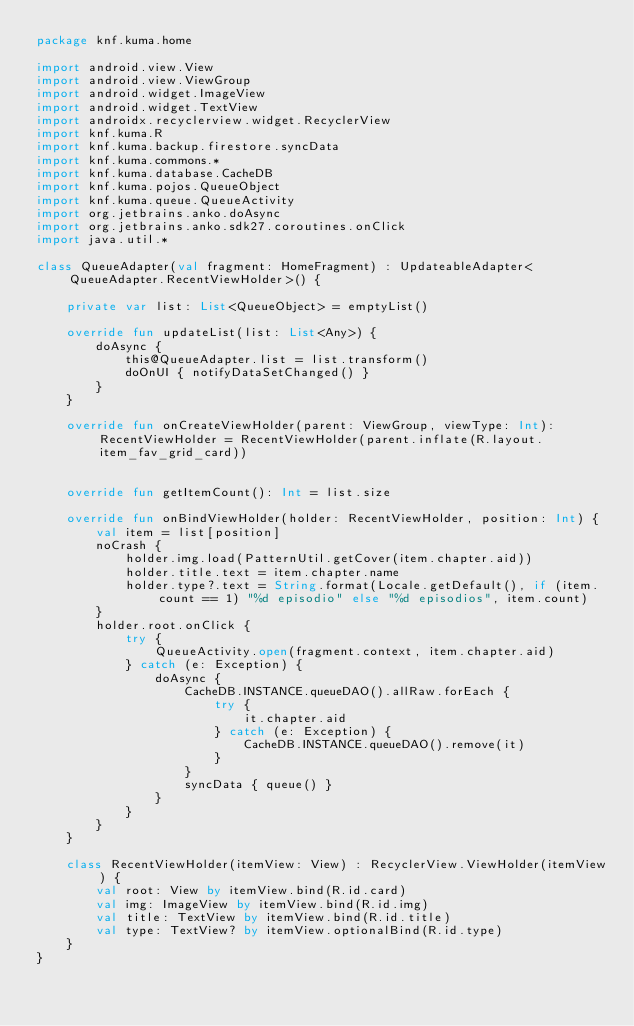<code> <loc_0><loc_0><loc_500><loc_500><_Kotlin_>package knf.kuma.home

import android.view.View
import android.view.ViewGroup
import android.widget.ImageView
import android.widget.TextView
import androidx.recyclerview.widget.RecyclerView
import knf.kuma.R
import knf.kuma.backup.firestore.syncData
import knf.kuma.commons.*
import knf.kuma.database.CacheDB
import knf.kuma.pojos.QueueObject
import knf.kuma.queue.QueueActivity
import org.jetbrains.anko.doAsync
import org.jetbrains.anko.sdk27.coroutines.onClick
import java.util.*

class QueueAdapter(val fragment: HomeFragment) : UpdateableAdapter<QueueAdapter.RecentViewHolder>() {

    private var list: List<QueueObject> = emptyList()

    override fun updateList(list: List<Any>) {
        doAsync {
            this@QueueAdapter.list = list.transform()
            doOnUI { notifyDataSetChanged() }
        }
    }

    override fun onCreateViewHolder(parent: ViewGroup, viewType: Int): RecentViewHolder = RecentViewHolder(parent.inflate(R.layout.item_fav_grid_card))


    override fun getItemCount(): Int = list.size

    override fun onBindViewHolder(holder: RecentViewHolder, position: Int) {
        val item = list[position]
        noCrash {
            holder.img.load(PatternUtil.getCover(item.chapter.aid))
            holder.title.text = item.chapter.name
            holder.type?.text = String.format(Locale.getDefault(), if (item.count == 1) "%d episodio" else "%d episodios", item.count)
        }
        holder.root.onClick {
            try {
                QueueActivity.open(fragment.context, item.chapter.aid)
            } catch (e: Exception) {
                doAsync {
                    CacheDB.INSTANCE.queueDAO().allRaw.forEach {
                        try {
                            it.chapter.aid
                        } catch (e: Exception) {
                            CacheDB.INSTANCE.queueDAO().remove(it)
                        }
                    }
                    syncData { queue() }
                }
            }
        }
    }

    class RecentViewHolder(itemView: View) : RecyclerView.ViewHolder(itemView) {
        val root: View by itemView.bind(R.id.card)
        val img: ImageView by itemView.bind(R.id.img)
        val title: TextView by itemView.bind(R.id.title)
        val type: TextView? by itemView.optionalBind(R.id.type)
    }
}</code> 